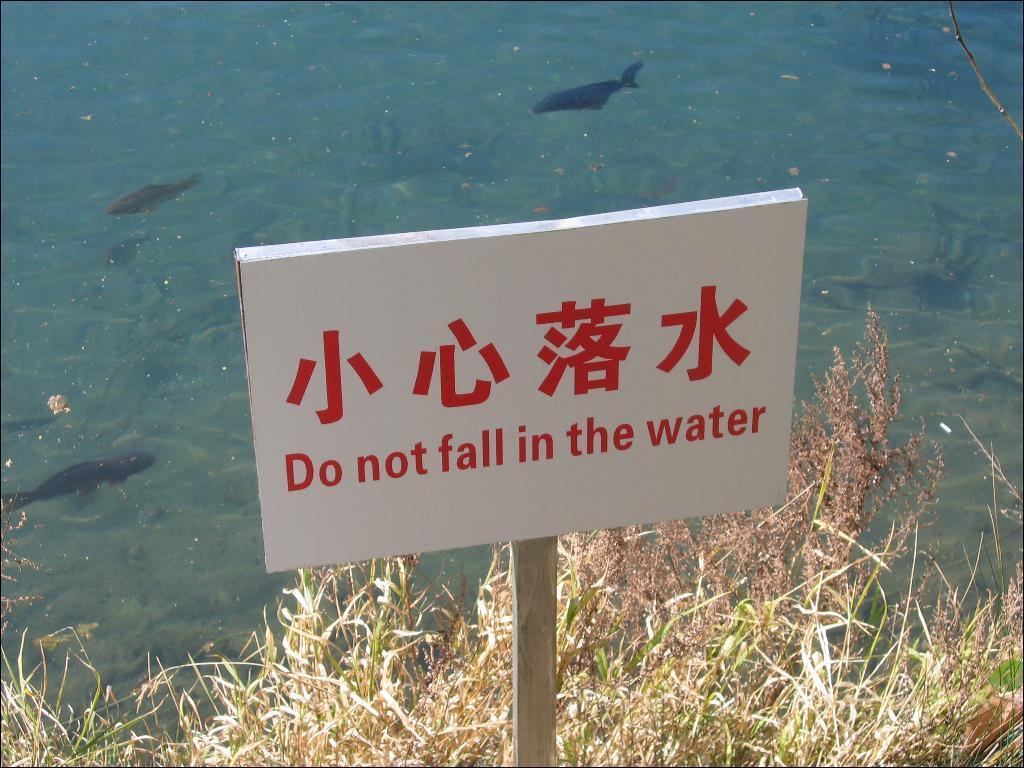Describe this image in one or two sentences. In this picture there is a board which is attached to this wooden stick. On the bottom we can see grass. In the background we can see many fish in the water. 